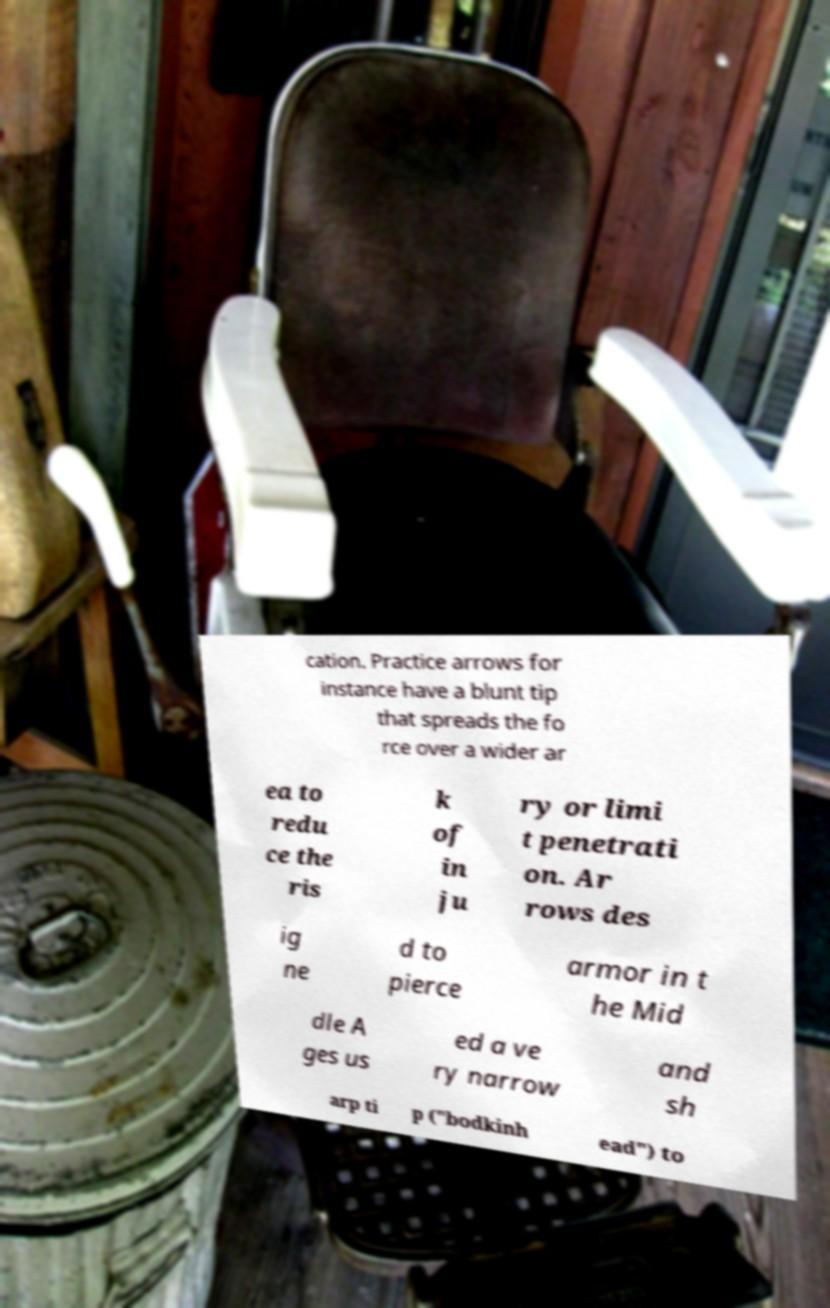Could you extract and type out the text from this image? cation. Practice arrows for instance have a blunt tip that spreads the fo rce over a wider ar ea to redu ce the ris k of in ju ry or limi t penetrati on. Ar rows des ig ne d to pierce armor in t he Mid dle A ges us ed a ve ry narrow and sh arp ti p ("bodkinh ead") to 